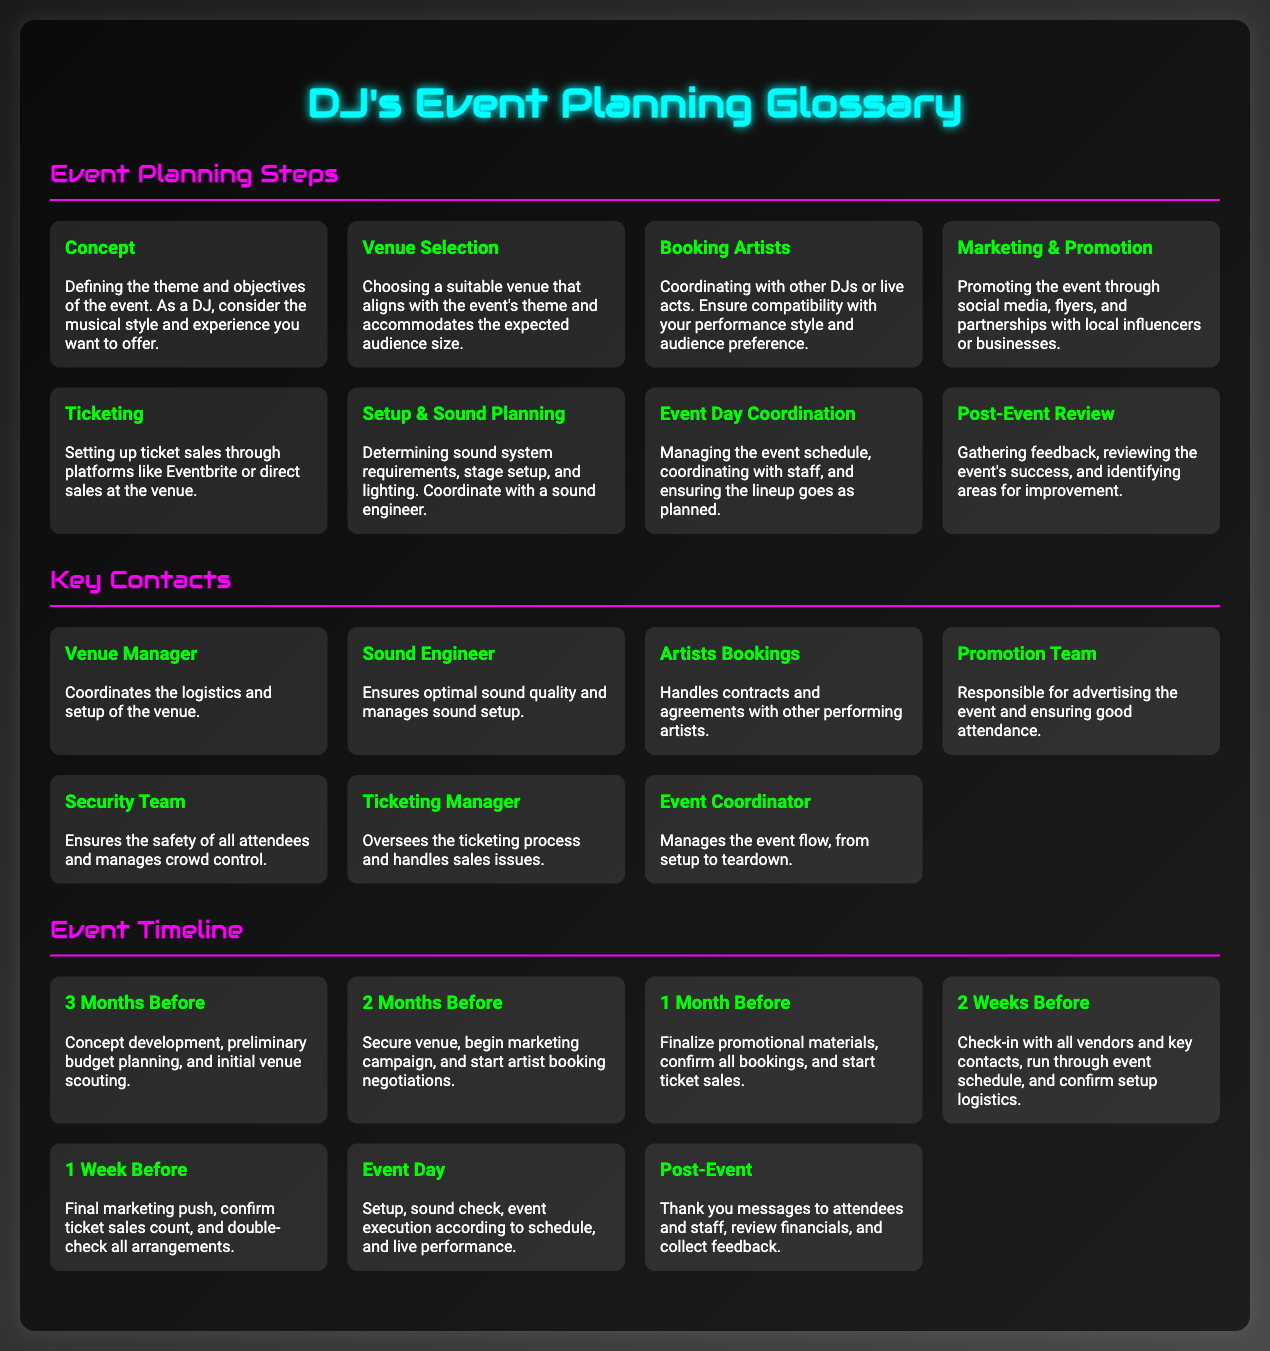What are the steps in event planning? The document outlines eight steps in event planning, including Concept, Venue Selection, and others.
Answer: Eight Who is responsible for coordinating the logistics of the venue? The document states that the Venue Manager handles logistics and setup.
Answer: Venue Manager What is the purpose of ticketing? The document mentions that ticketing is for setting up sales through platforms or direct sales.
Answer: Setting up ticket sales How far in advance should the concept be developed? According to the timeline, the concept should be developed three months before the event.
Answer: Three months What is the role of the Promotion Team? The Promotion Team's responsibility is to advertise the event and ensure good attendance.
Answer: Advertising the event How many weeks before the event should the final marketing push occur? The document states that the final marketing push occurs one week before the event.
Answer: One week What phase comes after booking artists? Following the booking of artists, the next phase is Marketing & Promotion as per the steps outlined.
Answer: Marketing & Promotion What are artists bookings responsible for? Artists bookings handle contracts and agreements with performing artists.
Answer: Contracts and agreements How many key contacts are listed in the document? The document lists seven key contacts involved in event planning.
Answer: Seven 